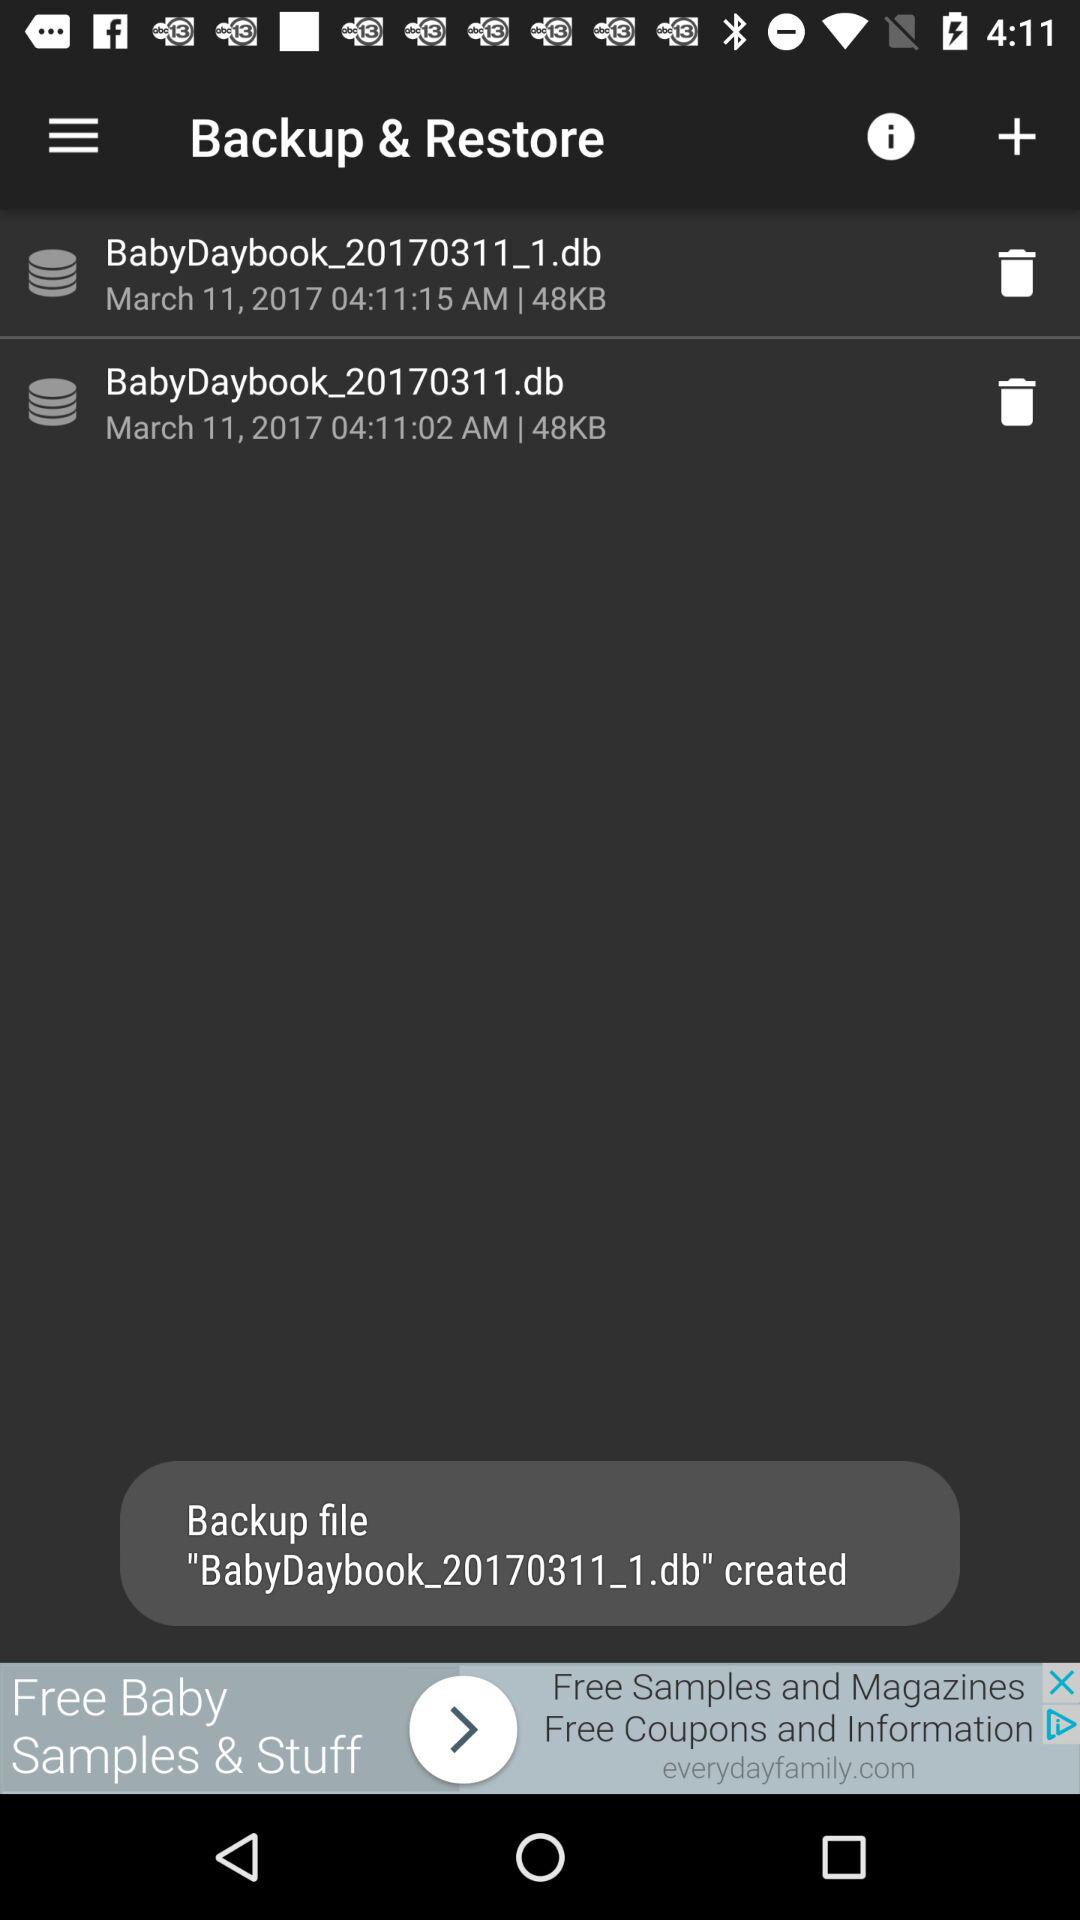How many backups are there in total?
Answer the question using a single word or phrase. 2 